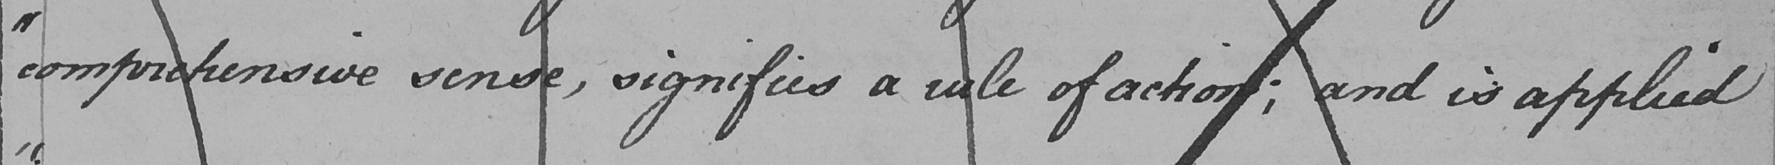What does this handwritten line say? " comprehensive venue , signifies a rule of action ; and is applied 